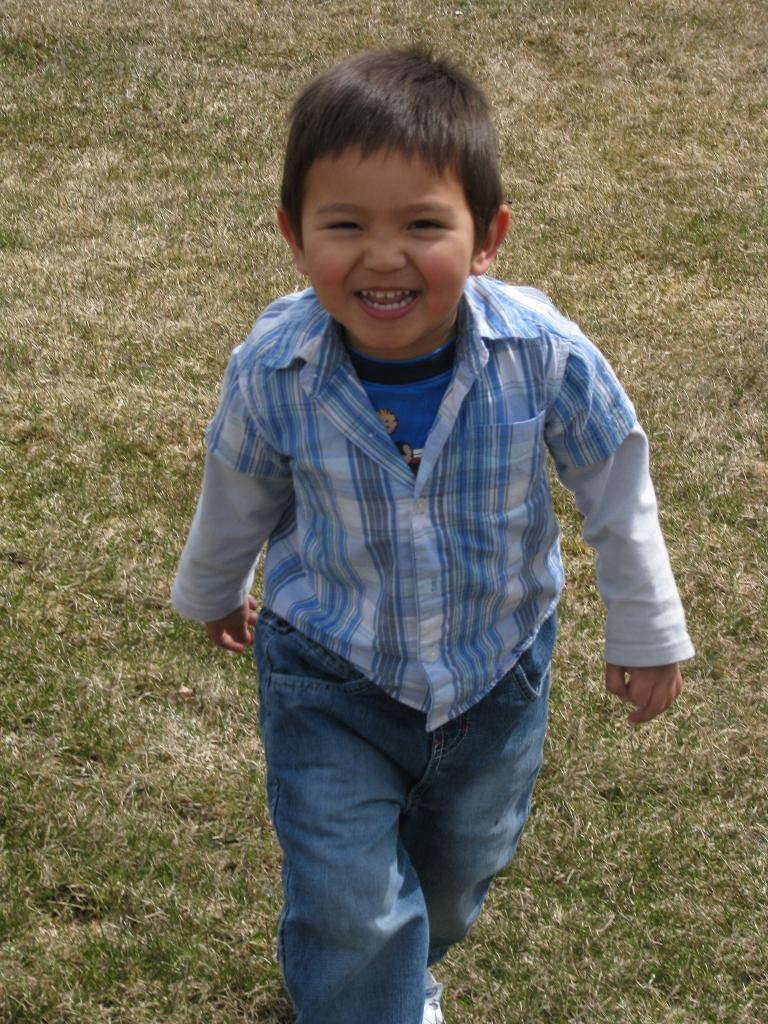What is the main subject of the image? The main subject of the image is a boy. What is the boy doing in the image? The boy is standing in the image. What is the boy's facial expression in the image? The boy is smiling in the image. What can be seen in the background of the image? There is grass in the background of the image. What type of tools does the carpenter have in the image? There is no carpenter present in the image; it features a boy standing and smiling. What type of prison can be seen in the image? There is no prison present in the image; it features a boy standing and smiling in front of grass. 